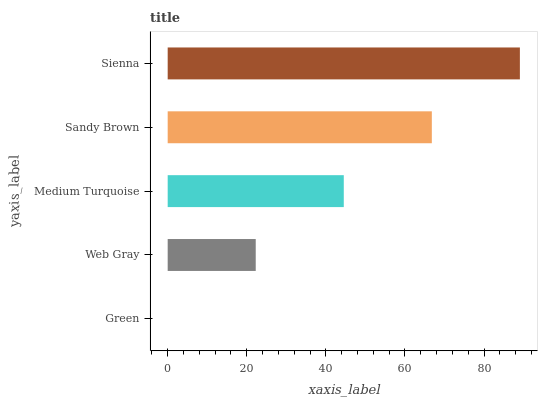Is Green the minimum?
Answer yes or no. Yes. Is Sienna the maximum?
Answer yes or no. Yes. Is Web Gray the minimum?
Answer yes or no. No. Is Web Gray the maximum?
Answer yes or no. No. Is Web Gray greater than Green?
Answer yes or no. Yes. Is Green less than Web Gray?
Answer yes or no. Yes. Is Green greater than Web Gray?
Answer yes or no. No. Is Web Gray less than Green?
Answer yes or no. No. Is Medium Turquoise the high median?
Answer yes or no. Yes. Is Medium Turquoise the low median?
Answer yes or no. Yes. Is Green the high median?
Answer yes or no. No. Is Sandy Brown the low median?
Answer yes or no. No. 